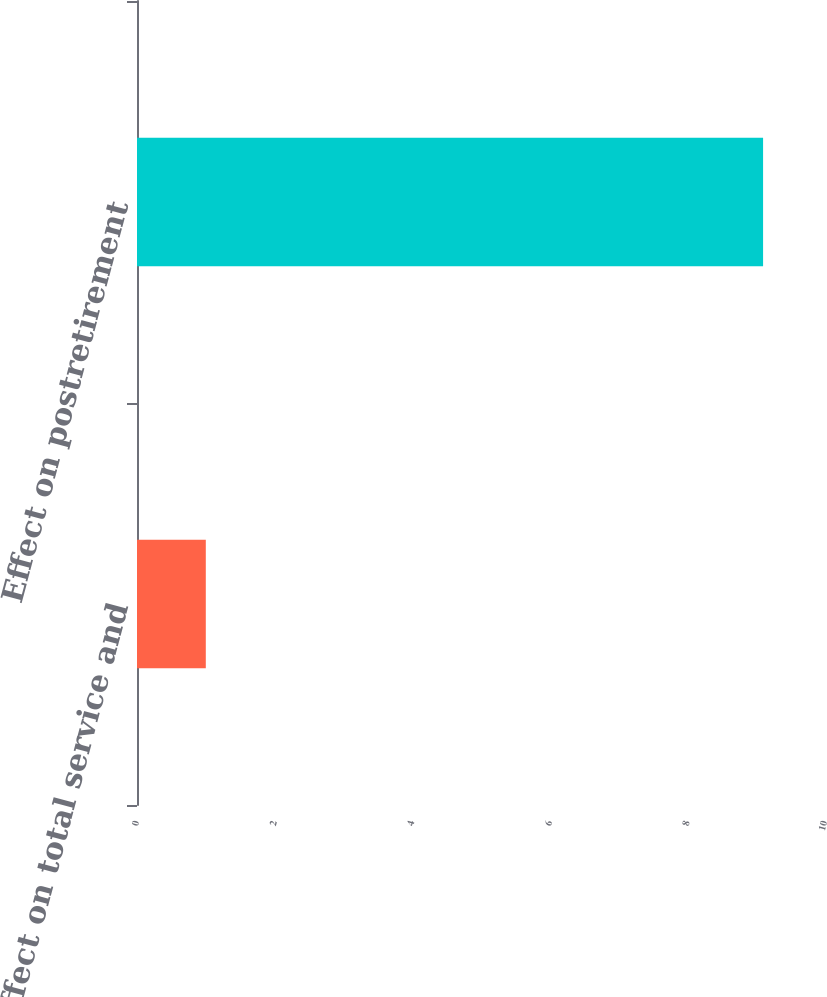Convert chart. <chart><loc_0><loc_0><loc_500><loc_500><bar_chart><fcel>Effect on total service and<fcel>Effect on postretirement<nl><fcel>1<fcel>9.1<nl></chart> 